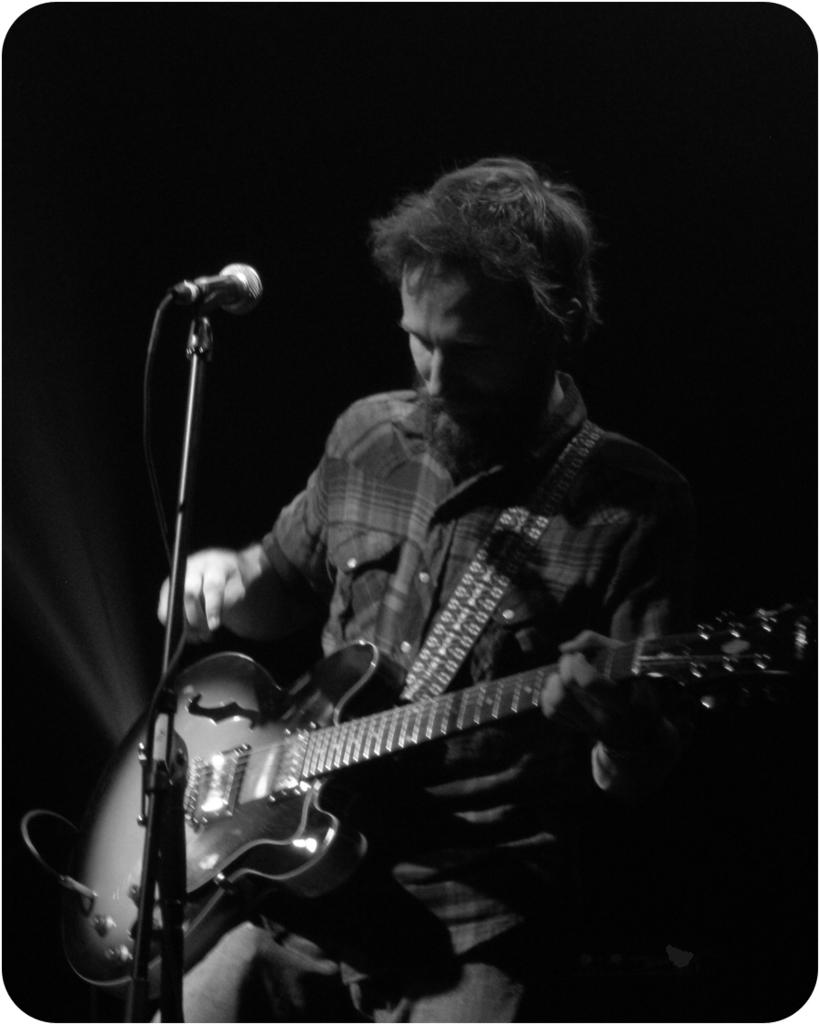What is the color scheme of the image? The image is in black and white. What can be seen in the image? There is a person in the image. What is the person holding? The person is holding a guitar. What is the person doing with the guitar? The person is moving the strings of the guitar. What is in front of the person? There is a microphone (mic) in front of the person. Can you see any whips being used in the image? No, there are no whips present in the image. What type of island is visible in the background of the image? There is no island visible in the image; it is a black and white image of a person holding a guitar and standing in front of a microphone. 